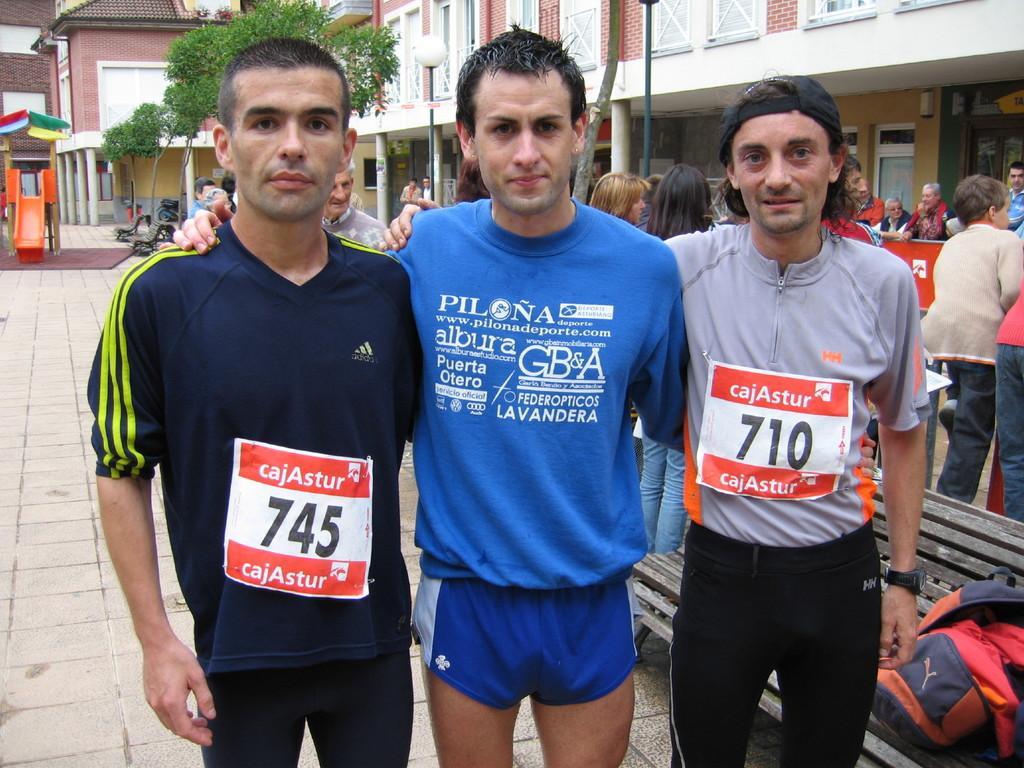Please provide a concise description of this image. In this image in the foreground there are three persons who are standing, and in the background there are a group of people and also we could see some trees, buildings, poles. At the bottom there is a walkway and on the right side there is one bench, on the bench there is one bag. 